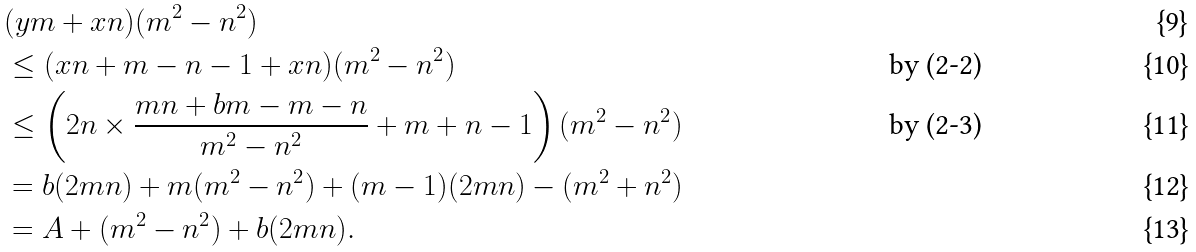<formula> <loc_0><loc_0><loc_500><loc_500>& ( y m + x n ) ( m ^ { 2 } - n ^ { 2 } ) \\ & \leq ( x n + m - n - 1 + x n ) ( m ^ { 2 } - n ^ { 2 } ) & \text {by (2-2)} \\ & \leq \left ( 2 n \times \frac { m n + b m - m - n } { m ^ { 2 } - n ^ { 2 } } + m + n - 1 \right ) ( m ^ { 2 } - n ^ { 2 } ) & \text {by (2-3)} \\ & = b ( 2 m n ) + m ( m ^ { 2 } - n ^ { 2 } ) + ( m - 1 ) ( 2 m n ) - ( m ^ { 2 } + n ^ { 2 } ) \\ & = A + ( m ^ { 2 } - n ^ { 2 } ) + b ( 2 m n ) .</formula> 